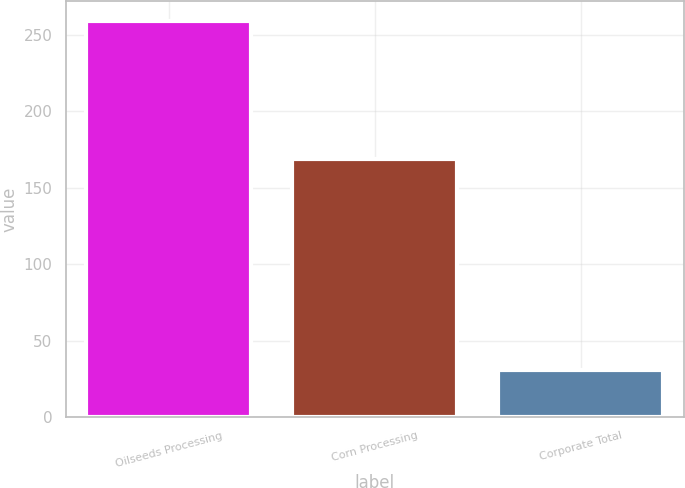Convert chart. <chart><loc_0><loc_0><loc_500><loc_500><bar_chart><fcel>Oilseeds Processing<fcel>Corn Processing<fcel>Corporate Total<nl><fcel>259<fcel>169<fcel>31<nl></chart> 